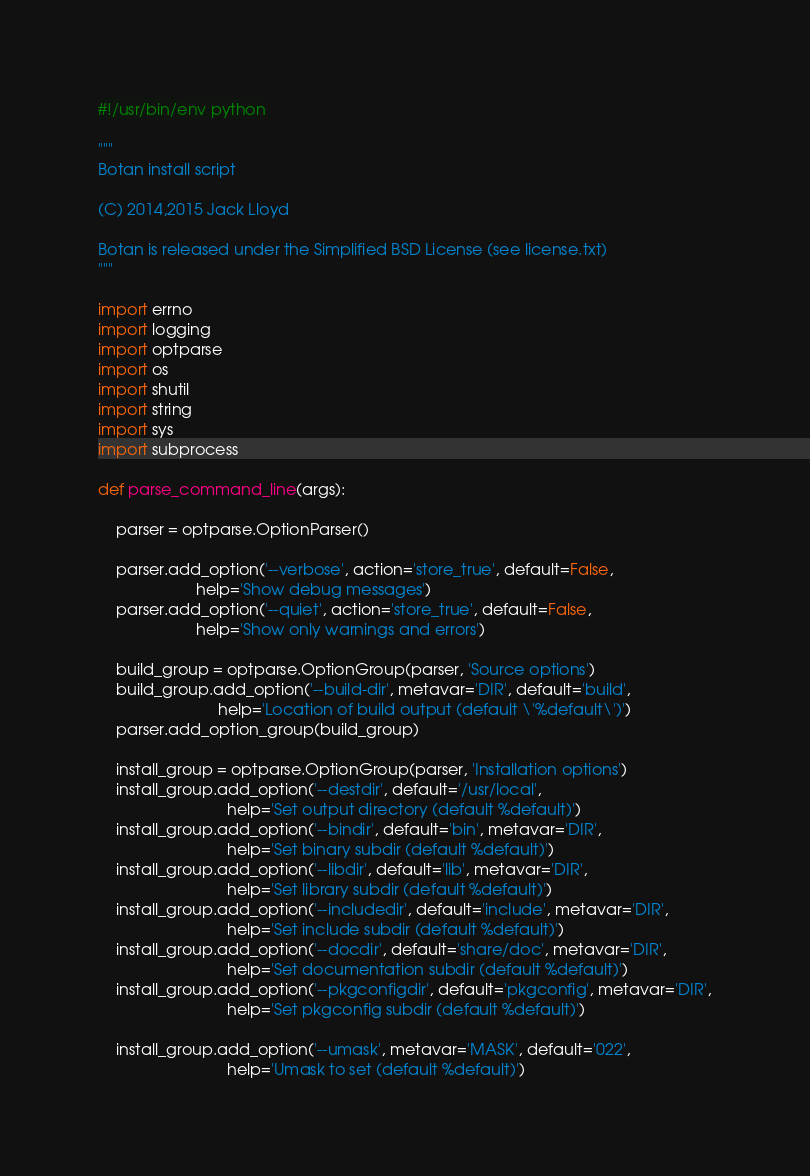<code> <loc_0><loc_0><loc_500><loc_500><_Python_>#!/usr/bin/env python

"""
Botan install script

(C) 2014,2015 Jack Lloyd

Botan is released under the Simplified BSD License (see license.txt)
"""

import errno
import logging
import optparse
import os
import shutil
import string
import sys
import subprocess

def parse_command_line(args):

    parser = optparse.OptionParser()

    parser.add_option('--verbose', action='store_true', default=False,
                      help='Show debug messages')
    parser.add_option('--quiet', action='store_true', default=False,
                      help='Show only warnings and errors')

    build_group = optparse.OptionGroup(parser, 'Source options')
    build_group.add_option('--build-dir', metavar='DIR', default='build',
                           help='Location of build output (default \'%default\')')
    parser.add_option_group(build_group)

    install_group = optparse.OptionGroup(parser, 'Installation options')
    install_group.add_option('--destdir', default='/usr/local',
                             help='Set output directory (default %default)')
    install_group.add_option('--bindir', default='bin', metavar='DIR',
                             help='Set binary subdir (default %default)')
    install_group.add_option('--libdir', default='lib', metavar='DIR',
                             help='Set library subdir (default %default)')
    install_group.add_option('--includedir', default='include', metavar='DIR',
                             help='Set include subdir (default %default)')
    install_group.add_option('--docdir', default='share/doc', metavar='DIR',
                             help='Set documentation subdir (default %default)')
    install_group.add_option('--pkgconfigdir', default='pkgconfig', metavar='DIR',
                             help='Set pkgconfig subdir (default %default)')

    install_group.add_option('--umask', metavar='MASK', default='022',
                             help='Umask to set (default %default)')</code> 